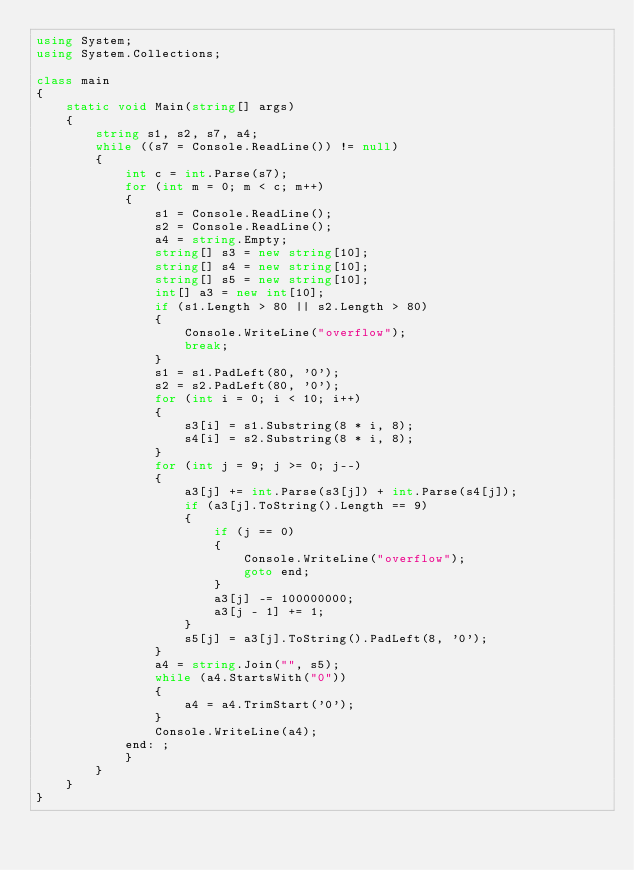<code> <loc_0><loc_0><loc_500><loc_500><_C#_>using System;
using System.Collections;

class main
{
    static void Main(string[] args)
    {
        string s1, s2, s7, a4;
        while ((s7 = Console.ReadLine()) != null)
        {
            int c = int.Parse(s7);
            for (int m = 0; m < c; m++)
            {
                s1 = Console.ReadLine();
                s2 = Console.ReadLine();
                a4 = string.Empty;
                string[] s3 = new string[10];
                string[] s4 = new string[10];
                string[] s5 = new string[10];
                int[] a3 = new int[10];
                if (s1.Length > 80 || s2.Length > 80)
                {
                    Console.WriteLine("overflow");
                    break;
                }
                s1 = s1.PadLeft(80, '0');
                s2 = s2.PadLeft(80, '0');
                for (int i = 0; i < 10; i++)
                {
                    s3[i] = s1.Substring(8 * i, 8);
                    s4[i] = s2.Substring(8 * i, 8);
                }
                for (int j = 9; j >= 0; j--)
                {
                    a3[j] += int.Parse(s3[j]) + int.Parse(s4[j]);
                    if (a3[j].ToString().Length == 9)
                    {
                        if (j == 0)
                        {
                            Console.WriteLine("overflow");
                            goto end;
                        }
                        a3[j] -= 100000000;
                        a3[j - 1] += 1;
                    }
                    s5[j] = a3[j].ToString().PadLeft(8, '0');
                }
                a4 = string.Join("", s5);
                while (a4.StartsWith("0"))
                {
                    a4 = a4.TrimStart('0');
                }
                Console.WriteLine(a4);
            end: ;
            }
        }    
    }
}</code> 